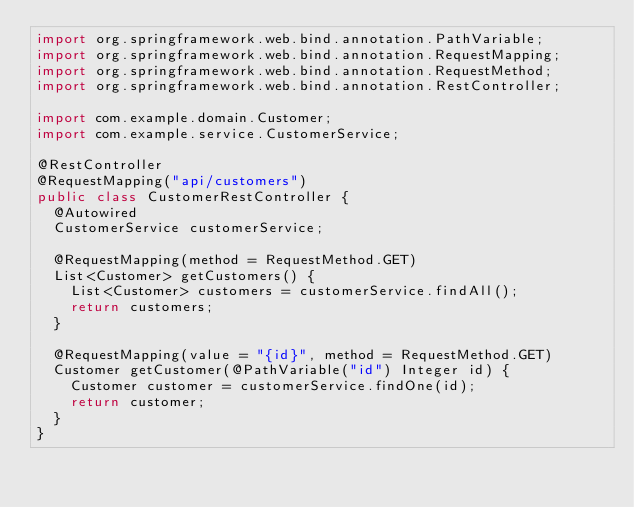Convert code to text. <code><loc_0><loc_0><loc_500><loc_500><_Java_>import org.springframework.web.bind.annotation.PathVariable;
import org.springframework.web.bind.annotation.RequestMapping;
import org.springframework.web.bind.annotation.RequestMethod;
import org.springframework.web.bind.annotation.RestController;

import com.example.domain.Customer;
import com.example.service.CustomerService;

@RestController
@RequestMapping("api/customers")
public class CustomerRestController {
	@Autowired
	CustomerService customerService;
	
	@RequestMapping(method = RequestMethod.GET)
	List<Customer> getCustomers() {
		List<Customer> customers = customerService.findAll();
		return customers;
	}
	
	@RequestMapping(value = "{id}", method = RequestMethod.GET)
	Customer getCustomer(@PathVariable("id") Integer id) {
		Customer customer = customerService.findOne(id);
		return customer;
	}
}
</code> 